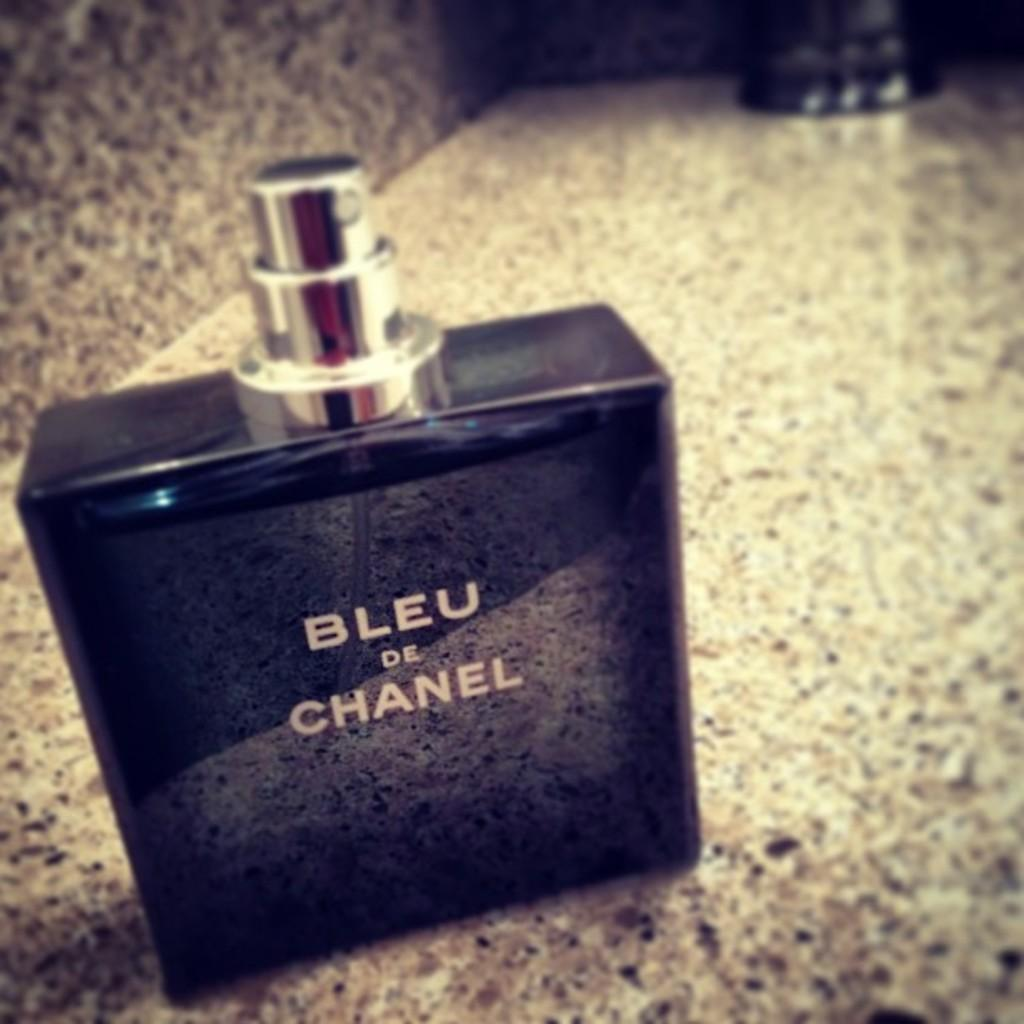<image>
Present a compact description of the photo's key features. A bottle of Bleu de Chanel on a counter 